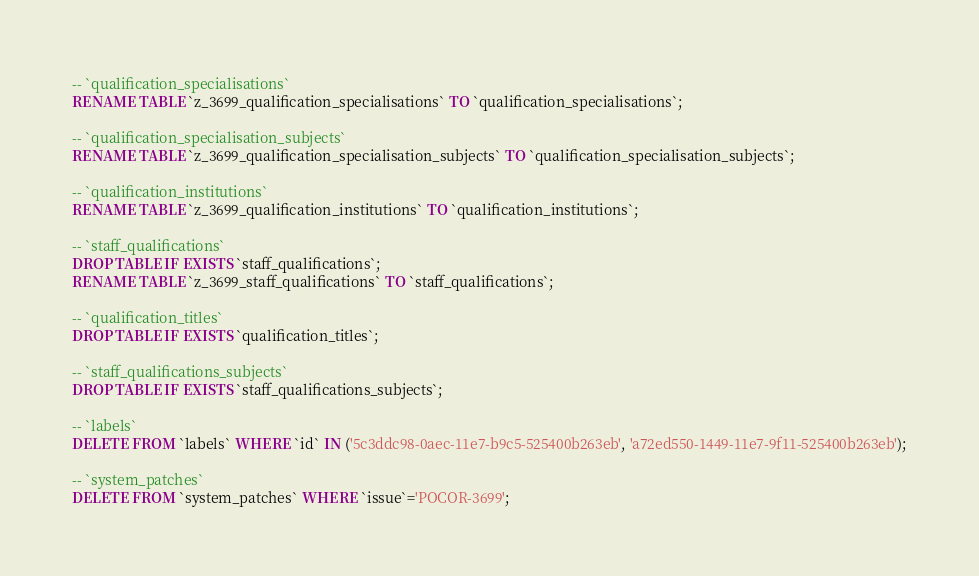<code> <loc_0><loc_0><loc_500><loc_500><_SQL_>-- `qualification_specialisations`
RENAME TABLE `z_3699_qualification_specialisations` TO `qualification_specialisations`;

-- `qualification_specialisation_subjects`
RENAME TABLE `z_3699_qualification_specialisation_subjects` TO `qualification_specialisation_subjects`;

-- `qualification_institutions`
RENAME TABLE `z_3699_qualification_institutions` TO `qualification_institutions`;

-- `staff_qualifications`
DROP TABLE IF EXISTS `staff_qualifications`;
RENAME TABLE `z_3699_staff_qualifications` TO `staff_qualifications`;

-- `qualification_titles`
DROP TABLE IF EXISTS `qualification_titles`;

-- `staff_qualifications_subjects`
DROP TABLE IF EXISTS `staff_qualifications_subjects`;

-- `labels`
DELETE FROM `labels` WHERE `id` IN ('5c3ddc98-0aec-11e7-b9c5-525400b263eb', 'a72ed550-1449-11e7-9f11-525400b263eb');

-- `system_patches`
DELETE FROM `system_patches` WHERE `issue`='POCOR-3699';
</code> 